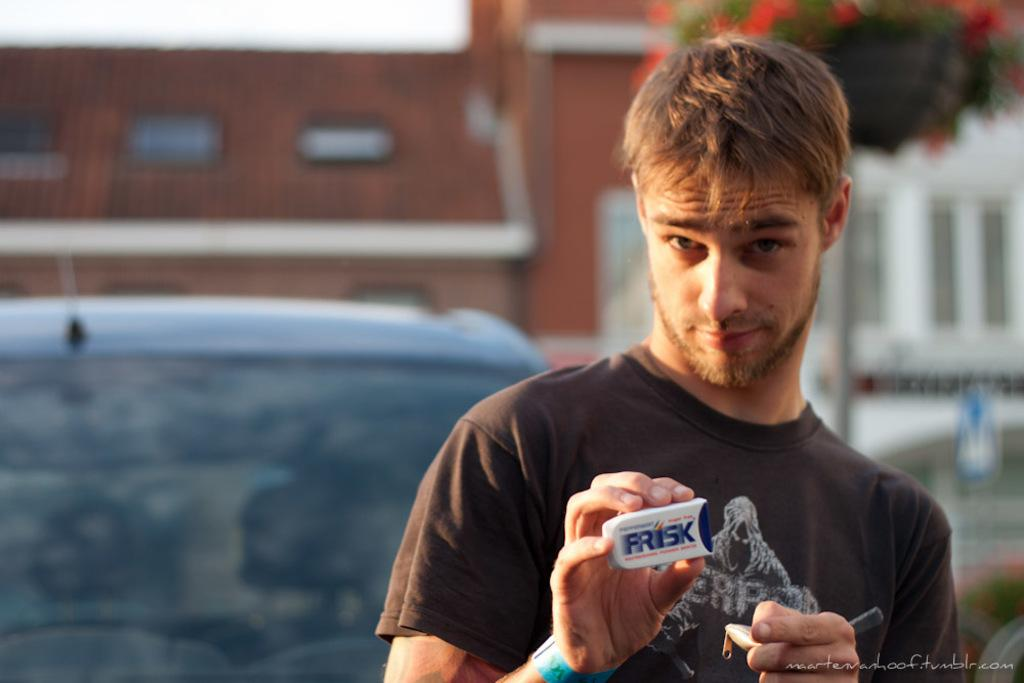What is the man holding in the image? The facts do not specify what the man is holding. What can be seen on the left side of the image? There is a car on the left side of the image. What is visible in the background of the image? There are buildings and a tree in the background of the image. How would you describe the background of the image? The background appears blurry. What type of gold reward is the man receiving in the image? There is no gold reward or any indication of a reward in the image. 